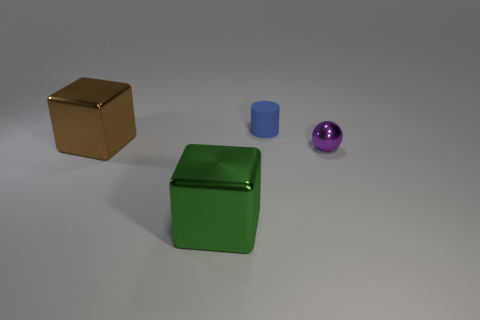Add 4 big green metal spheres. How many objects exist? 8 Subtract all balls. How many objects are left? 3 Add 1 large metallic things. How many large metallic things exist? 3 Subtract 0 yellow cubes. How many objects are left? 4 Subtract all green cubes. Subtract all large shiny objects. How many objects are left? 1 Add 4 big shiny cubes. How many big shiny cubes are left? 6 